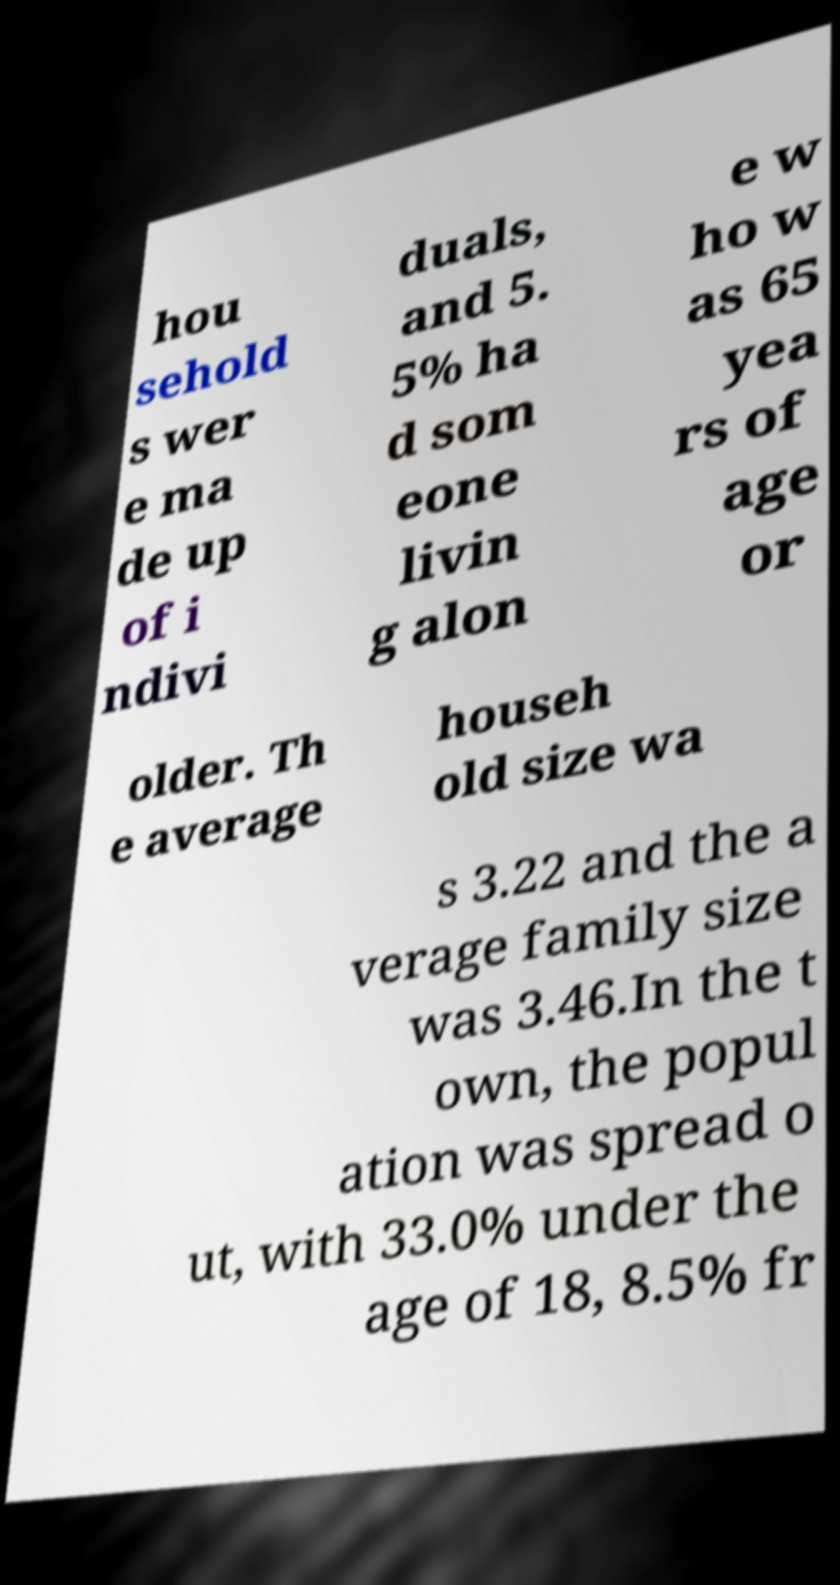Can you read and provide the text displayed in the image?This photo seems to have some interesting text. Can you extract and type it out for me? hou sehold s wer e ma de up of i ndivi duals, and 5. 5% ha d som eone livin g alon e w ho w as 65 yea rs of age or older. Th e average househ old size wa s 3.22 and the a verage family size was 3.46.In the t own, the popul ation was spread o ut, with 33.0% under the age of 18, 8.5% fr 